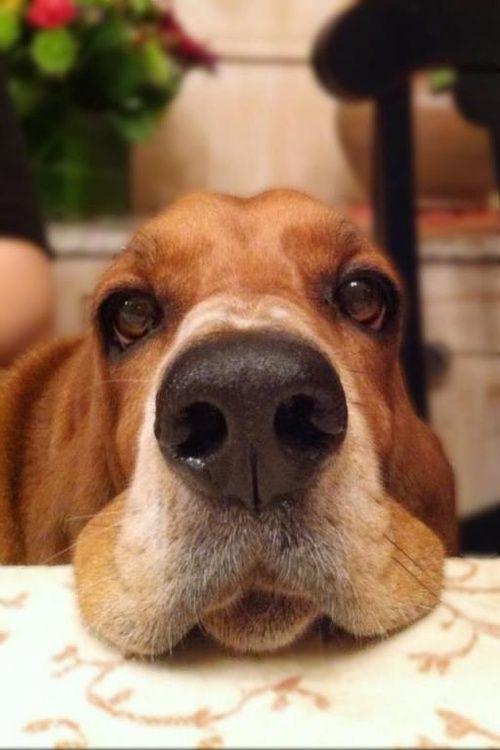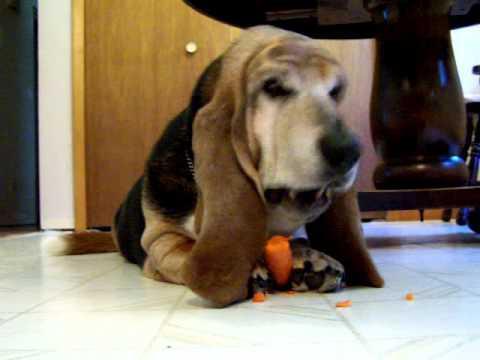The first image is the image on the left, the second image is the image on the right. Assess this claim about the two images: "In one of the images there is a dog eating a carrot.". Correct or not? Answer yes or no. Yes. The first image is the image on the left, the second image is the image on the right. Evaluate the accuracy of this statement regarding the images: "One of the images shows at least one Basset Hound with something in their mouth.". Is it true? Answer yes or no. No. 